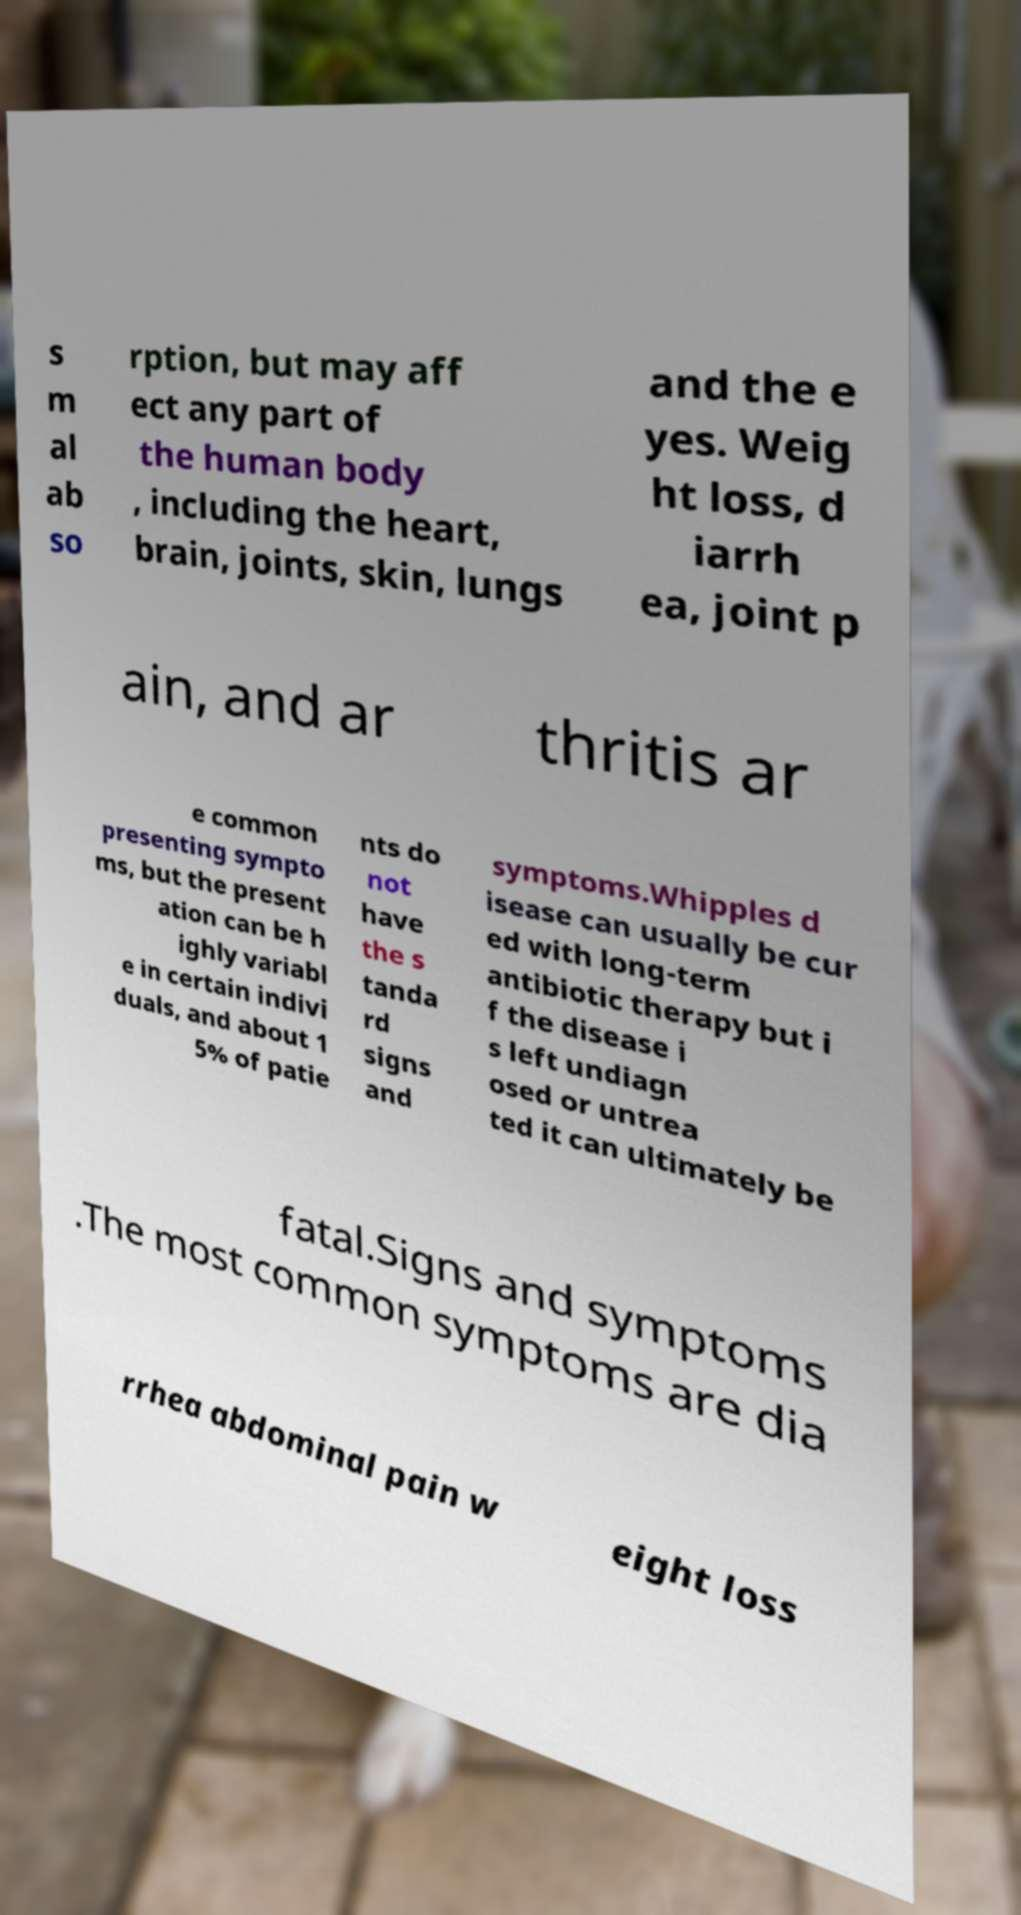Can you accurately transcribe the text from the provided image for me? s m al ab so rption, but may aff ect any part of the human body , including the heart, brain, joints, skin, lungs and the e yes. Weig ht loss, d iarrh ea, joint p ain, and ar thritis ar e common presenting sympto ms, but the present ation can be h ighly variabl e in certain indivi duals, and about 1 5% of patie nts do not have the s tanda rd signs and symptoms.Whipples d isease can usually be cur ed with long-term antibiotic therapy but i f the disease i s left undiagn osed or untrea ted it can ultimately be fatal.Signs and symptoms .The most common symptoms are dia rrhea abdominal pain w eight loss 